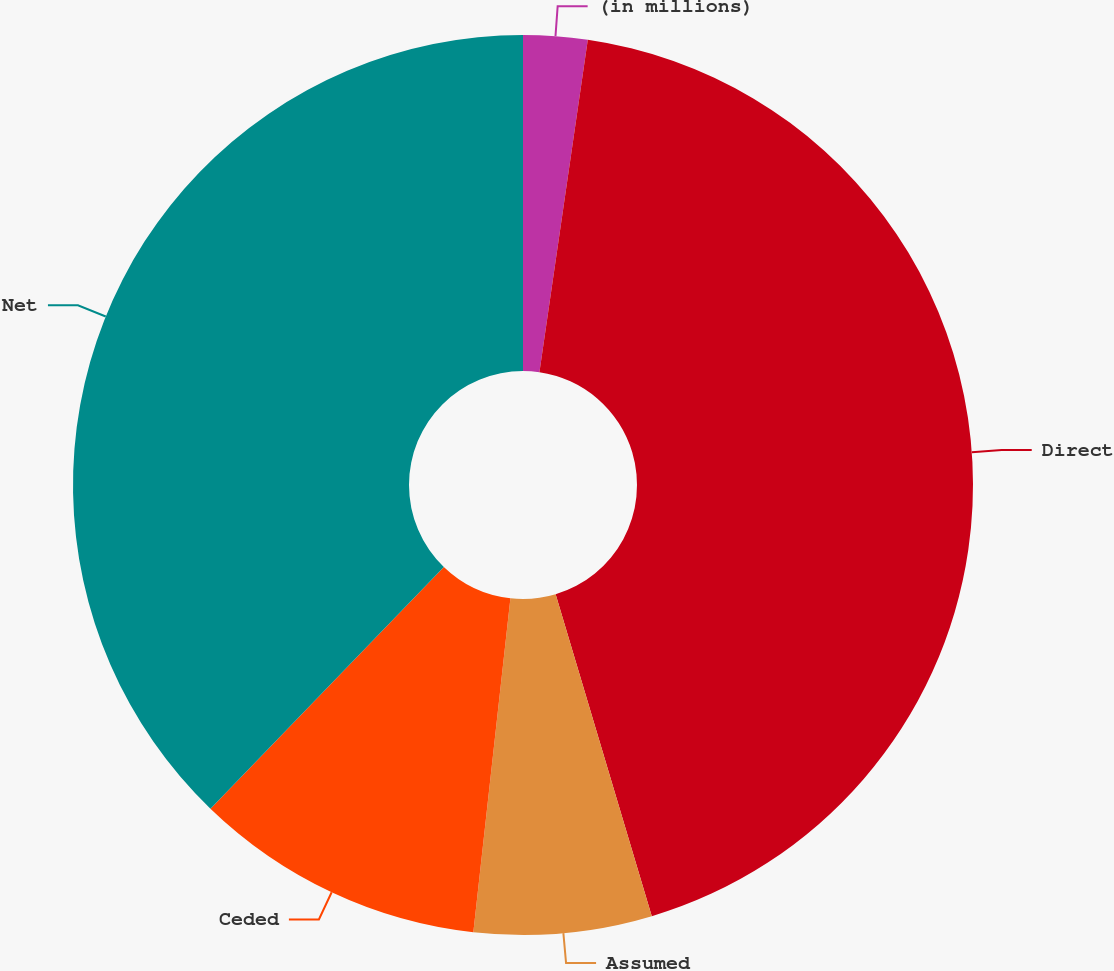Convert chart to OTSL. <chart><loc_0><loc_0><loc_500><loc_500><pie_chart><fcel>(in millions)<fcel>Direct<fcel>Assumed<fcel>Ceded<fcel>Net<nl><fcel>2.3%<fcel>43.08%<fcel>6.38%<fcel>10.46%<fcel>37.78%<nl></chart> 